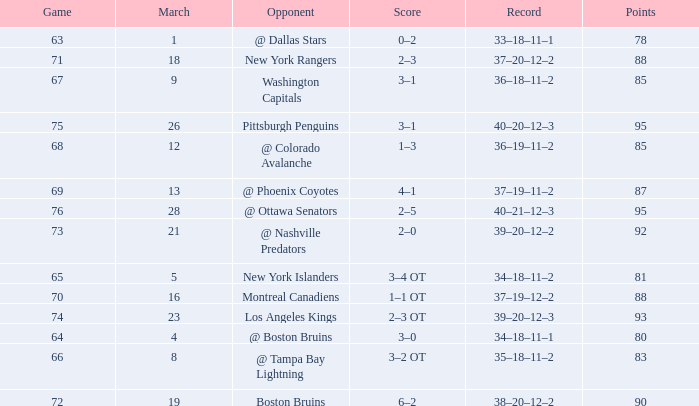In which game are the points below 92 and the score falls within the 1-3 range, while being the highest of its kind? 68.0. I'm looking to parse the entire table for insights. Could you assist me with that? {'header': ['Game', 'March', 'Opponent', 'Score', 'Record', 'Points'], 'rows': [['63', '1', '@ Dallas Stars', '0–2', '33–18–11–1', '78'], ['71', '18', 'New York Rangers', '2–3', '37–20–12–2', '88'], ['67', '9', 'Washington Capitals', '3–1', '36–18–11–2', '85'], ['75', '26', 'Pittsburgh Penguins', '3–1', '40–20–12–3', '95'], ['68', '12', '@ Colorado Avalanche', '1–3', '36–19–11–2', '85'], ['69', '13', '@ Phoenix Coyotes', '4–1', '37–19–11–2', '87'], ['76', '28', '@ Ottawa Senators', '2–5', '40–21–12–3', '95'], ['73', '21', '@ Nashville Predators', '2–0', '39–20–12–2', '92'], ['65', '5', 'New York Islanders', '3–4 OT', '34–18–11–2', '81'], ['70', '16', 'Montreal Canadiens', '1–1 OT', '37–19–12–2', '88'], ['74', '23', 'Los Angeles Kings', '2–3 OT', '39–20–12–3', '93'], ['64', '4', '@ Boston Bruins', '3–0', '34–18–11–1', '80'], ['66', '8', '@ Tampa Bay Lightning', '3–2 OT', '35–18–11–2', '83'], ['72', '19', 'Boston Bruins', '6–2', '38–20–12–2', '90']]} 